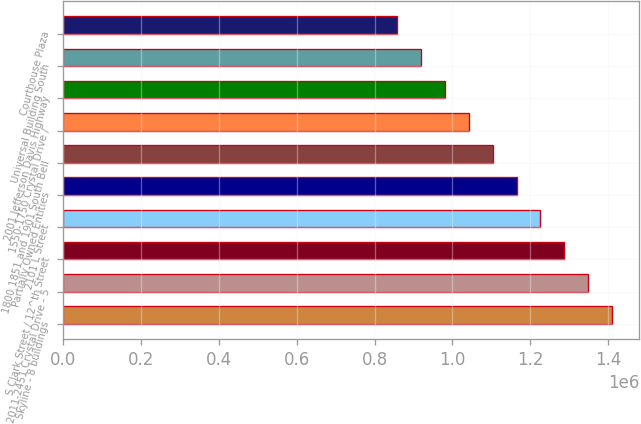Convert chart. <chart><loc_0><loc_0><loc_500><loc_500><bar_chart><fcel>Skyline - 8 buildings<fcel>2011-2451 Crystal Drive - 5<fcel>S Clark Street / 12^th Street<fcel>2101 L Street<fcel>Partially Owned Entities<fcel>1800 1851 and 1901 South Bell<fcel>1550-1750 Crystal Drive /<fcel>2001 Jefferson Davis Highway<fcel>Universal Building South<fcel>Courthouse Plaza<nl><fcel>1.4096e+06<fcel>1.3484e+06<fcel>1.2872e+06<fcel>1.226e+06<fcel>1.1648e+06<fcel>1.1036e+06<fcel>1.0424e+06<fcel>981200<fcel>920000<fcel>858800<nl></chart> 